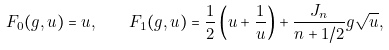Convert formula to latex. <formula><loc_0><loc_0><loc_500><loc_500>F _ { 0 } ( g , u ) = u , \quad F _ { 1 } ( g , u ) = \frac { 1 } { 2 } \left ( u + \frac { 1 } { u } \right ) + \frac { J _ { n } } { n + 1 / 2 } g \sqrt { u } ,</formula> 